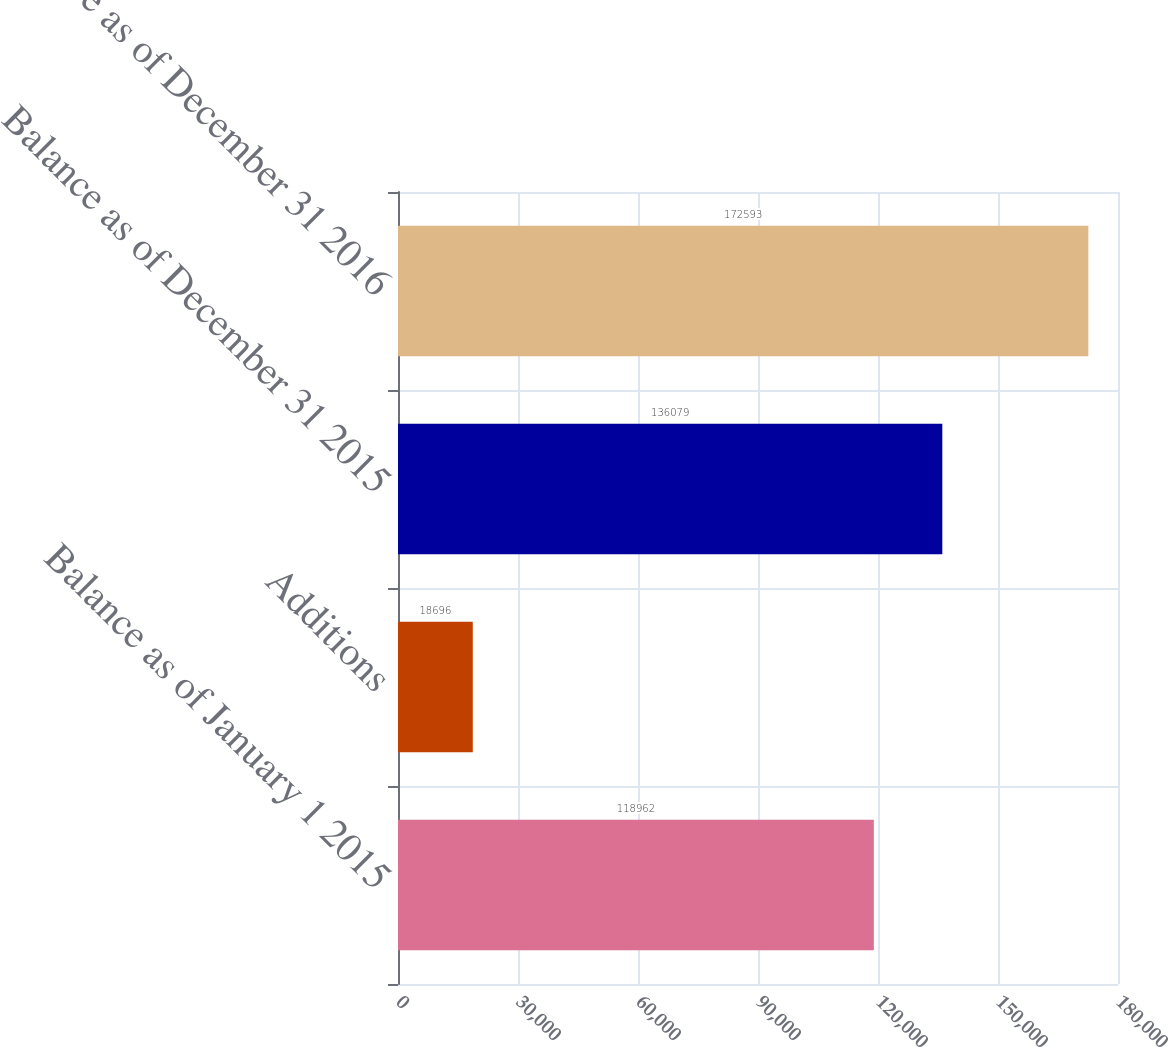Convert chart to OTSL. <chart><loc_0><loc_0><loc_500><loc_500><bar_chart><fcel>Balance as of January 1 2015<fcel>Additions<fcel>Balance as of December 31 2015<fcel>Balance as of December 31 2016<nl><fcel>118962<fcel>18696<fcel>136079<fcel>172593<nl></chart> 